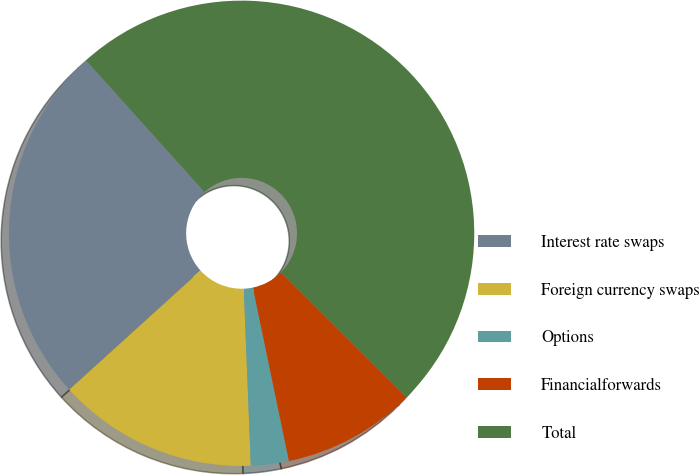Convert chart to OTSL. <chart><loc_0><loc_0><loc_500><loc_500><pie_chart><fcel>Interest rate swaps<fcel>Foreign currency swaps<fcel>Options<fcel>Financialforwards<fcel>Total<nl><fcel>25.06%<fcel>13.91%<fcel>2.63%<fcel>9.26%<fcel>49.13%<nl></chart> 